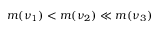Convert formula to latex. <formula><loc_0><loc_0><loc_500><loc_500>m ( \nu _ { 1 } ) < m ( \nu _ { 2 } ) \ll m ( \nu _ { 3 } )</formula> 